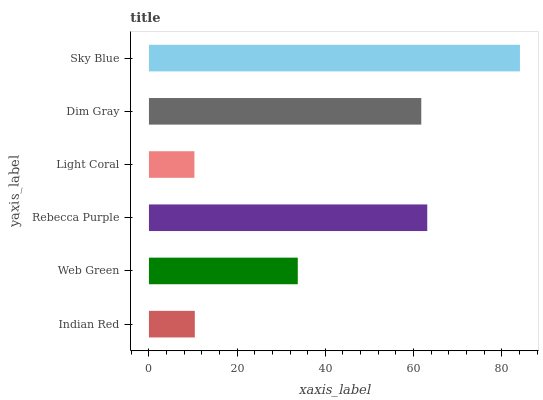Is Light Coral the minimum?
Answer yes or no. Yes. Is Sky Blue the maximum?
Answer yes or no. Yes. Is Web Green the minimum?
Answer yes or no. No. Is Web Green the maximum?
Answer yes or no. No. Is Web Green greater than Indian Red?
Answer yes or no. Yes. Is Indian Red less than Web Green?
Answer yes or no. Yes. Is Indian Red greater than Web Green?
Answer yes or no. No. Is Web Green less than Indian Red?
Answer yes or no. No. Is Dim Gray the high median?
Answer yes or no. Yes. Is Web Green the low median?
Answer yes or no. Yes. Is Rebecca Purple the high median?
Answer yes or no. No. Is Dim Gray the low median?
Answer yes or no. No. 